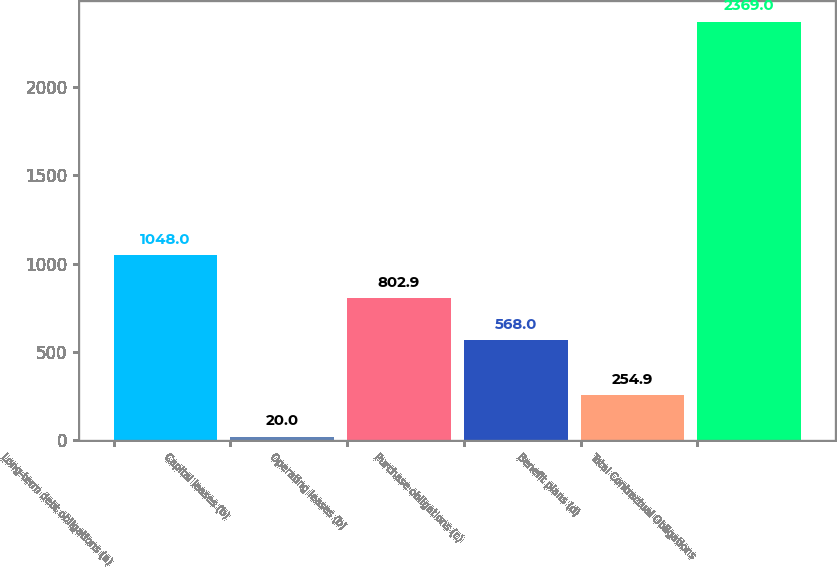Convert chart to OTSL. <chart><loc_0><loc_0><loc_500><loc_500><bar_chart><fcel>Long-term debt obligations (a)<fcel>Capital leases (b)<fcel>Operating leases (b)<fcel>Purchase obligations (c)<fcel>Benefit plans (d)<fcel>Total Contractual Obligations<nl><fcel>1048<fcel>20<fcel>802.9<fcel>568<fcel>254.9<fcel>2369<nl></chart> 